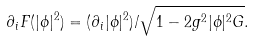<formula> <loc_0><loc_0><loc_500><loc_500>\partial _ { i } F ( | \phi | ^ { 2 } ) = ( \partial _ { i } | \phi | ^ { 2 } ) / \sqrt { 1 - 2 g ^ { 2 } | \phi | ^ { 2 } G } .</formula> 